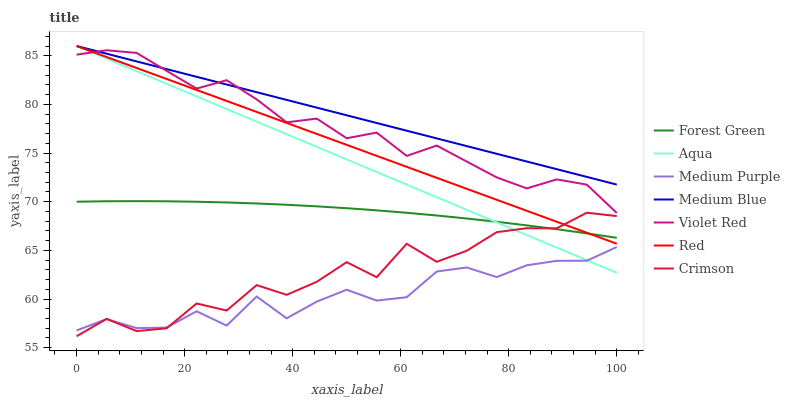Does Medium Purple have the minimum area under the curve?
Answer yes or no. Yes. Does Medium Blue have the maximum area under the curve?
Answer yes or no. Yes. Does Aqua have the minimum area under the curve?
Answer yes or no. No. Does Aqua have the maximum area under the curve?
Answer yes or no. No. Is Medium Blue the smoothest?
Answer yes or no. Yes. Is Crimson the roughest?
Answer yes or no. Yes. Is Aqua the smoothest?
Answer yes or no. No. Is Aqua the roughest?
Answer yes or no. No. Does Crimson have the lowest value?
Answer yes or no. Yes. Does Aqua have the lowest value?
Answer yes or no. No. Does Red have the highest value?
Answer yes or no. Yes. Does Medium Purple have the highest value?
Answer yes or no. No. Is Medium Purple less than Medium Blue?
Answer yes or no. Yes. Is Medium Blue greater than Forest Green?
Answer yes or no. Yes. Does Aqua intersect Medium Blue?
Answer yes or no. Yes. Is Aqua less than Medium Blue?
Answer yes or no. No. Is Aqua greater than Medium Blue?
Answer yes or no. No. Does Medium Purple intersect Medium Blue?
Answer yes or no. No. 